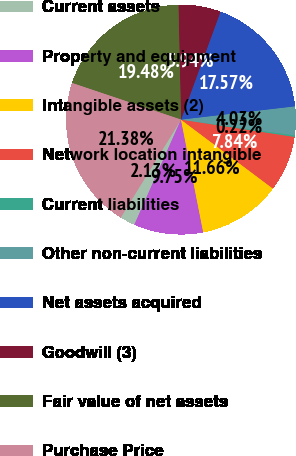<chart> <loc_0><loc_0><loc_500><loc_500><pie_chart><fcel>Current assets<fcel>Property and equipment<fcel>Intangible assets (2)<fcel>Network location intangible<fcel>Current liabilities<fcel>Other non-current liabilities<fcel>Net assets acquired<fcel>Goodwill (3)<fcel>Fair value of net assets<fcel>Purchase Price<nl><fcel>2.13%<fcel>9.75%<fcel>11.66%<fcel>7.84%<fcel>0.22%<fcel>4.03%<fcel>17.57%<fcel>5.94%<fcel>19.48%<fcel>21.38%<nl></chart> 